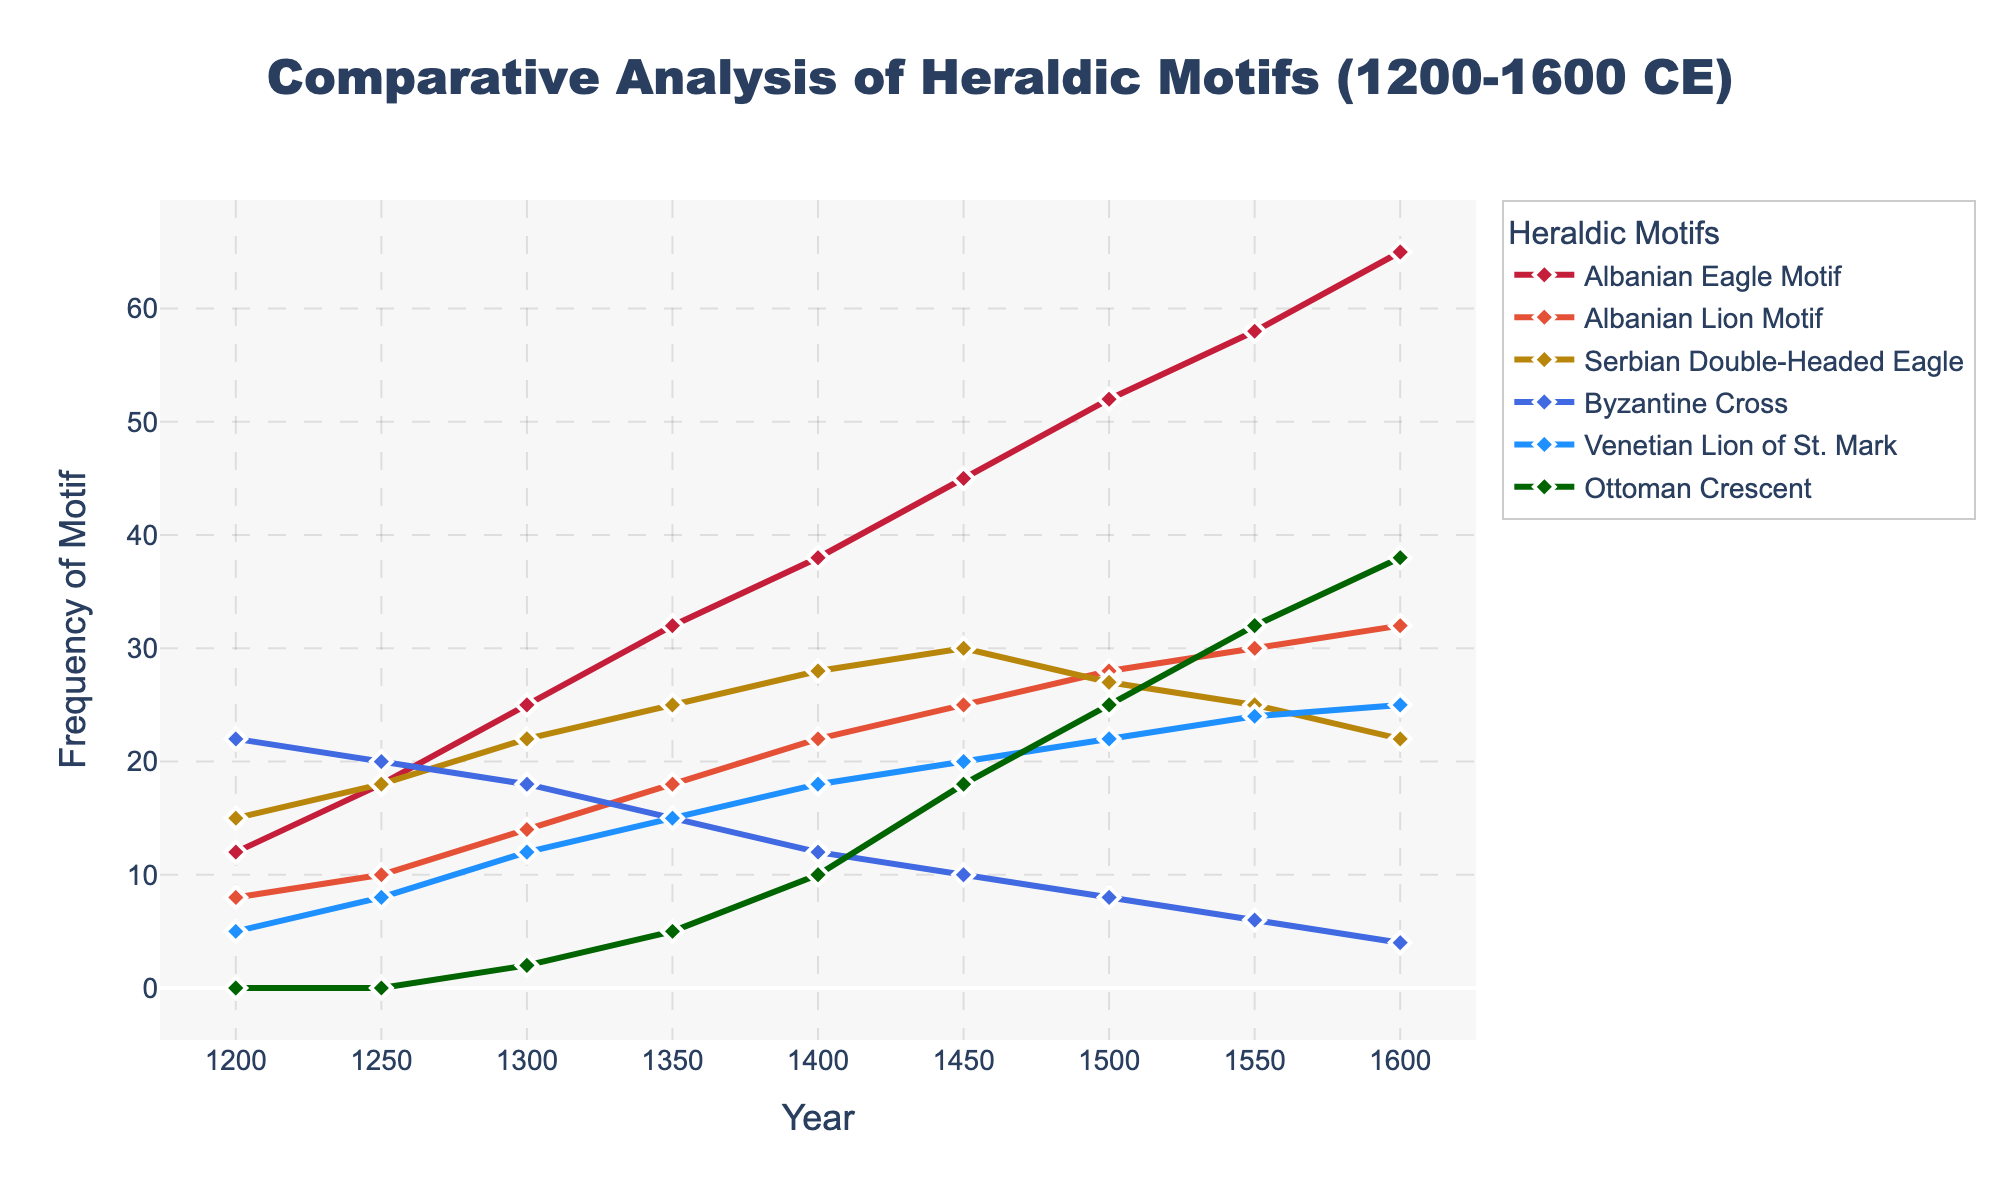What heraldic motif had the highest frequency in 1300 CE? By looking at the figure, find the motif with the highest point in 1300 CE. The 'Byzantine Cross' with a frequency of 22 was the highest among all motifs.
Answer: Byzantine Cross Which region saw the highest increase in motif frequency from 1200 to 1600 for the Albanian Eagle Motif and how much was the increase? Calculate the difference in frequency for the Albanian Eagle Motif between 1600 and 1200 by subtracting the frequency in 1200 from that in 1600 (65 - 12 = 53).
Answer: 53 Compared to the Venetian Lion of St. Mark, how did the frequency of the Serbian Double-Headed Eagle change from 1400 to 1500? Check the difference in frequency for both motifs between 1400 and 1500. The Serbian Double-Headed Eagle increased by 2 (30 - 28), while the Venetian Lion increased by 4 (22 - 18).
Answer: The Serbian Double-Headed Eagle increased less (+2) compared to the Venetian Lion (+4) Visually, which motif had the most consistent increase in the frequency over time? Examine the slopes of all lines across the figure to identify the motif with the steadiest upward trend. The Albanian Eagle Motif shows the most consistent increase.
Answer: Albanian Eagle Motif Compare the frequencies of the Ottoman Crescent in 1200 and 1600 CE and determine the percentage increase. Calculate the frequency difference (38 - 0 = 38) and then the percentage increase (38/0, noting that this is an incremental appearance, not applicable for zero base but shows introduction).
Answer: Introduction of Ottoman Crescent, historically 38x based if compared What was the total frequency of the Byzantine Cross and Venetian Lion of St. Mark combined in 1450? Sum the frequencies of the Byzantine Cross and Venetian Lion in 1450 (10 + 20 = 30).
Answer: 30 How did the frequency of the Albanian Lion Motif change between 1350 and 1550? Calculate the difference (30 - 18 = 12) to find the change in frequency.
Answer: Increased by 12 Which motif had the sharpest decline from its peak, and what was the magnitude of the decline? Identify the highest and lowest points for all motifs. The Serbian Double-Headed Eagle declined from 30 (1450) to 22 (1600), a magnitude of 8.
Answer: Serbian Double-Headed Eagle, 8 